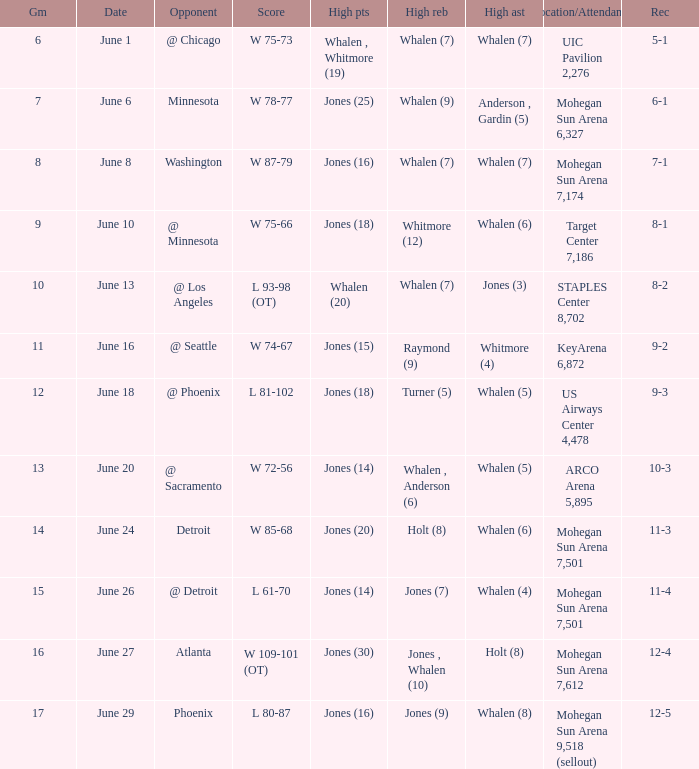Who had the high points on june 8? Jones (16). 